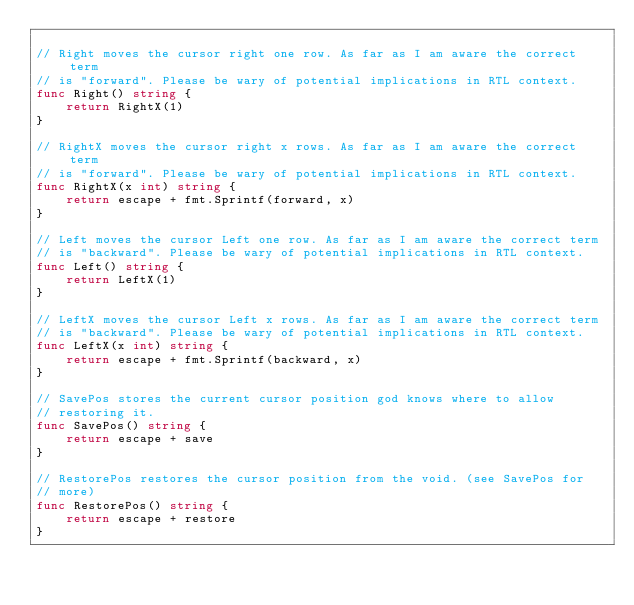Convert code to text. <code><loc_0><loc_0><loc_500><loc_500><_Go_>
// Right moves the cursor right one row. As far as I am aware the correct term
// is "forward". Please be wary of potential implications in RTL context.
func Right() string {
	return RightX(1)
}

// RightX moves the cursor right x rows. As far as I am aware the correct term
// is "forward". Please be wary of potential implications in RTL context.
func RightX(x int) string {
	return escape + fmt.Sprintf(forward, x)
}

// Left moves the cursor Left one row. As far as I am aware the correct term
// is "backward". Please be wary of potential implications in RTL context.
func Left() string {
	return LeftX(1)
}

// LeftX moves the cursor Left x rows. As far as I am aware the correct term
// is "backward". Please be wary of potential implications in RTL context.
func LeftX(x int) string {
	return escape + fmt.Sprintf(backward, x)
}

// SavePos stores the current cursor position god knows where to allow
// restoring it.
func SavePos() string {
	return escape + save
}

// RestorePos restores the cursor position from the void. (see SavePos for
// more)
func RestorePos() string {
	return escape + restore
}
</code> 